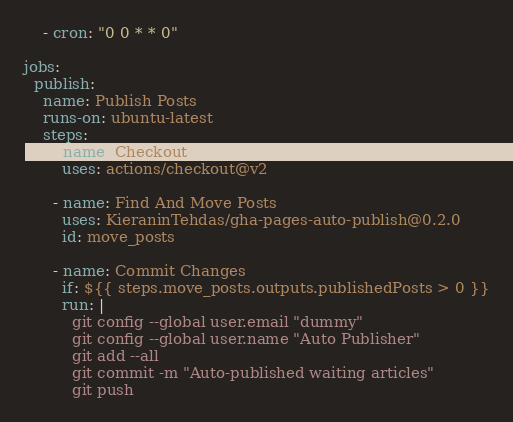Convert code to text. <code><loc_0><loc_0><loc_500><loc_500><_YAML_>    - cron: "0 0 * * 0"

jobs:
  publish:
    name: Publish Posts
    runs-on: ubuntu-latest
    steps:
      - name: Checkout
        uses: actions/checkout@v2

      - name: Find And Move Posts
        uses: KieraninTehdas/gha-pages-auto-publish@0.2.0
        id: move_posts

      - name: Commit Changes
        if: ${{ steps.move_posts.outputs.publishedPosts > 0 }}
        run: |
          git config --global user.email "dummy"
          git config --global user.name "Auto Publisher"
          git add --all
          git commit -m "Auto-published waiting articles"
          git push
</code> 